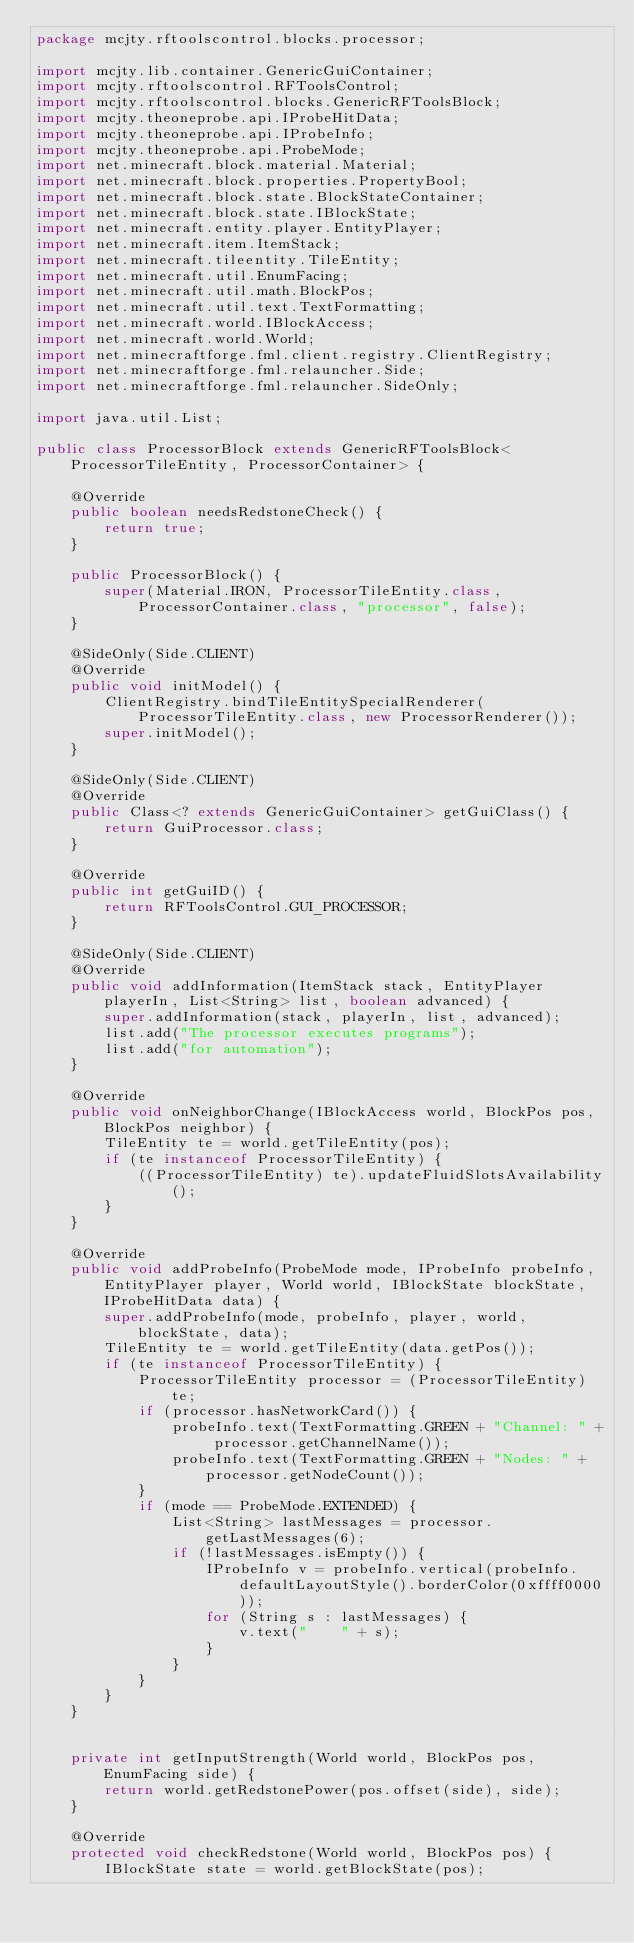Convert code to text. <code><loc_0><loc_0><loc_500><loc_500><_Java_>package mcjty.rftoolscontrol.blocks.processor;

import mcjty.lib.container.GenericGuiContainer;
import mcjty.rftoolscontrol.RFToolsControl;
import mcjty.rftoolscontrol.blocks.GenericRFToolsBlock;
import mcjty.theoneprobe.api.IProbeHitData;
import mcjty.theoneprobe.api.IProbeInfo;
import mcjty.theoneprobe.api.ProbeMode;
import net.minecraft.block.material.Material;
import net.minecraft.block.properties.PropertyBool;
import net.minecraft.block.state.BlockStateContainer;
import net.minecraft.block.state.IBlockState;
import net.minecraft.entity.player.EntityPlayer;
import net.minecraft.item.ItemStack;
import net.minecraft.tileentity.TileEntity;
import net.minecraft.util.EnumFacing;
import net.minecraft.util.math.BlockPos;
import net.minecraft.util.text.TextFormatting;
import net.minecraft.world.IBlockAccess;
import net.minecraft.world.World;
import net.minecraftforge.fml.client.registry.ClientRegistry;
import net.minecraftforge.fml.relauncher.Side;
import net.minecraftforge.fml.relauncher.SideOnly;

import java.util.List;

public class ProcessorBlock extends GenericRFToolsBlock<ProcessorTileEntity, ProcessorContainer> {

    @Override
    public boolean needsRedstoneCheck() {
        return true;
    }

    public ProcessorBlock() {
        super(Material.IRON, ProcessorTileEntity.class, ProcessorContainer.class, "processor", false);
    }

    @SideOnly(Side.CLIENT)
    @Override
    public void initModel() {
        ClientRegistry.bindTileEntitySpecialRenderer(ProcessorTileEntity.class, new ProcessorRenderer());
        super.initModel();
    }

    @SideOnly(Side.CLIENT)
    @Override
    public Class<? extends GenericGuiContainer> getGuiClass() {
        return GuiProcessor.class;
    }

    @Override
    public int getGuiID() {
        return RFToolsControl.GUI_PROCESSOR;
    }

    @SideOnly(Side.CLIENT)
    @Override
    public void addInformation(ItemStack stack, EntityPlayer playerIn, List<String> list, boolean advanced) {
        super.addInformation(stack, playerIn, list, advanced);
        list.add("The processor executes programs");
        list.add("for automation");
    }

    @Override
    public void onNeighborChange(IBlockAccess world, BlockPos pos, BlockPos neighbor) {
        TileEntity te = world.getTileEntity(pos);
        if (te instanceof ProcessorTileEntity) {
            ((ProcessorTileEntity) te).updateFluidSlotsAvailability();
        }
    }

    @Override
    public void addProbeInfo(ProbeMode mode, IProbeInfo probeInfo, EntityPlayer player, World world, IBlockState blockState, IProbeHitData data) {
        super.addProbeInfo(mode, probeInfo, player, world, blockState, data);
        TileEntity te = world.getTileEntity(data.getPos());
        if (te instanceof ProcessorTileEntity) {
            ProcessorTileEntity processor = (ProcessorTileEntity) te;
            if (processor.hasNetworkCard()) {
                probeInfo.text(TextFormatting.GREEN + "Channel: " + processor.getChannelName());
                probeInfo.text(TextFormatting.GREEN + "Nodes: " + processor.getNodeCount());
            }
            if (mode == ProbeMode.EXTENDED) {
                List<String> lastMessages = processor.getLastMessages(6);
                if (!lastMessages.isEmpty()) {
                    IProbeInfo v = probeInfo.vertical(probeInfo.defaultLayoutStyle().borderColor(0xffff0000));
                    for (String s : lastMessages) {
                        v.text("    " + s);
                    }
                }
            }
        }
    }


    private int getInputStrength(World world, BlockPos pos, EnumFacing side) {
        return world.getRedstonePower(pos.offset(side), side);
    }

    @Override
    protected void checkRedstone(World world, BlockPos pos) {
        IBlockState state = world.getBlockState(pos);</code> 